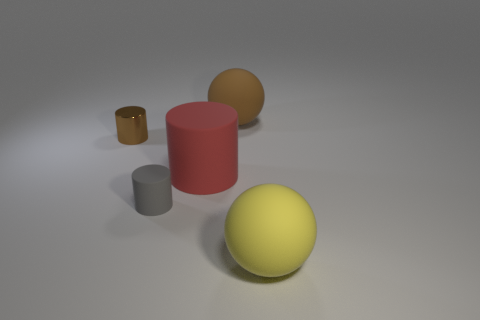Subtract all large cylinders. How many cylinders are left? 2 Subtract all yellow balls. How many balls are left? 1 Add 5 brown balls. How many objects exist? 10 Subtract all balls. How many objects are left? 3 Add 4 large yellow balls. How many large yellow balls are left? 5 Add 5 yellow metallic things. How many yellow metallic things exist? 5 Subtract 0 blue blocks. How many objects are left? 5 Subtract 2 spheres. How many spheres are left? 0 Subtract all green balls. Subtract all blue blocks. How many balls are left? 2 Subtract all gray cubes. Subtract all brown things. How many objects are left? 3 